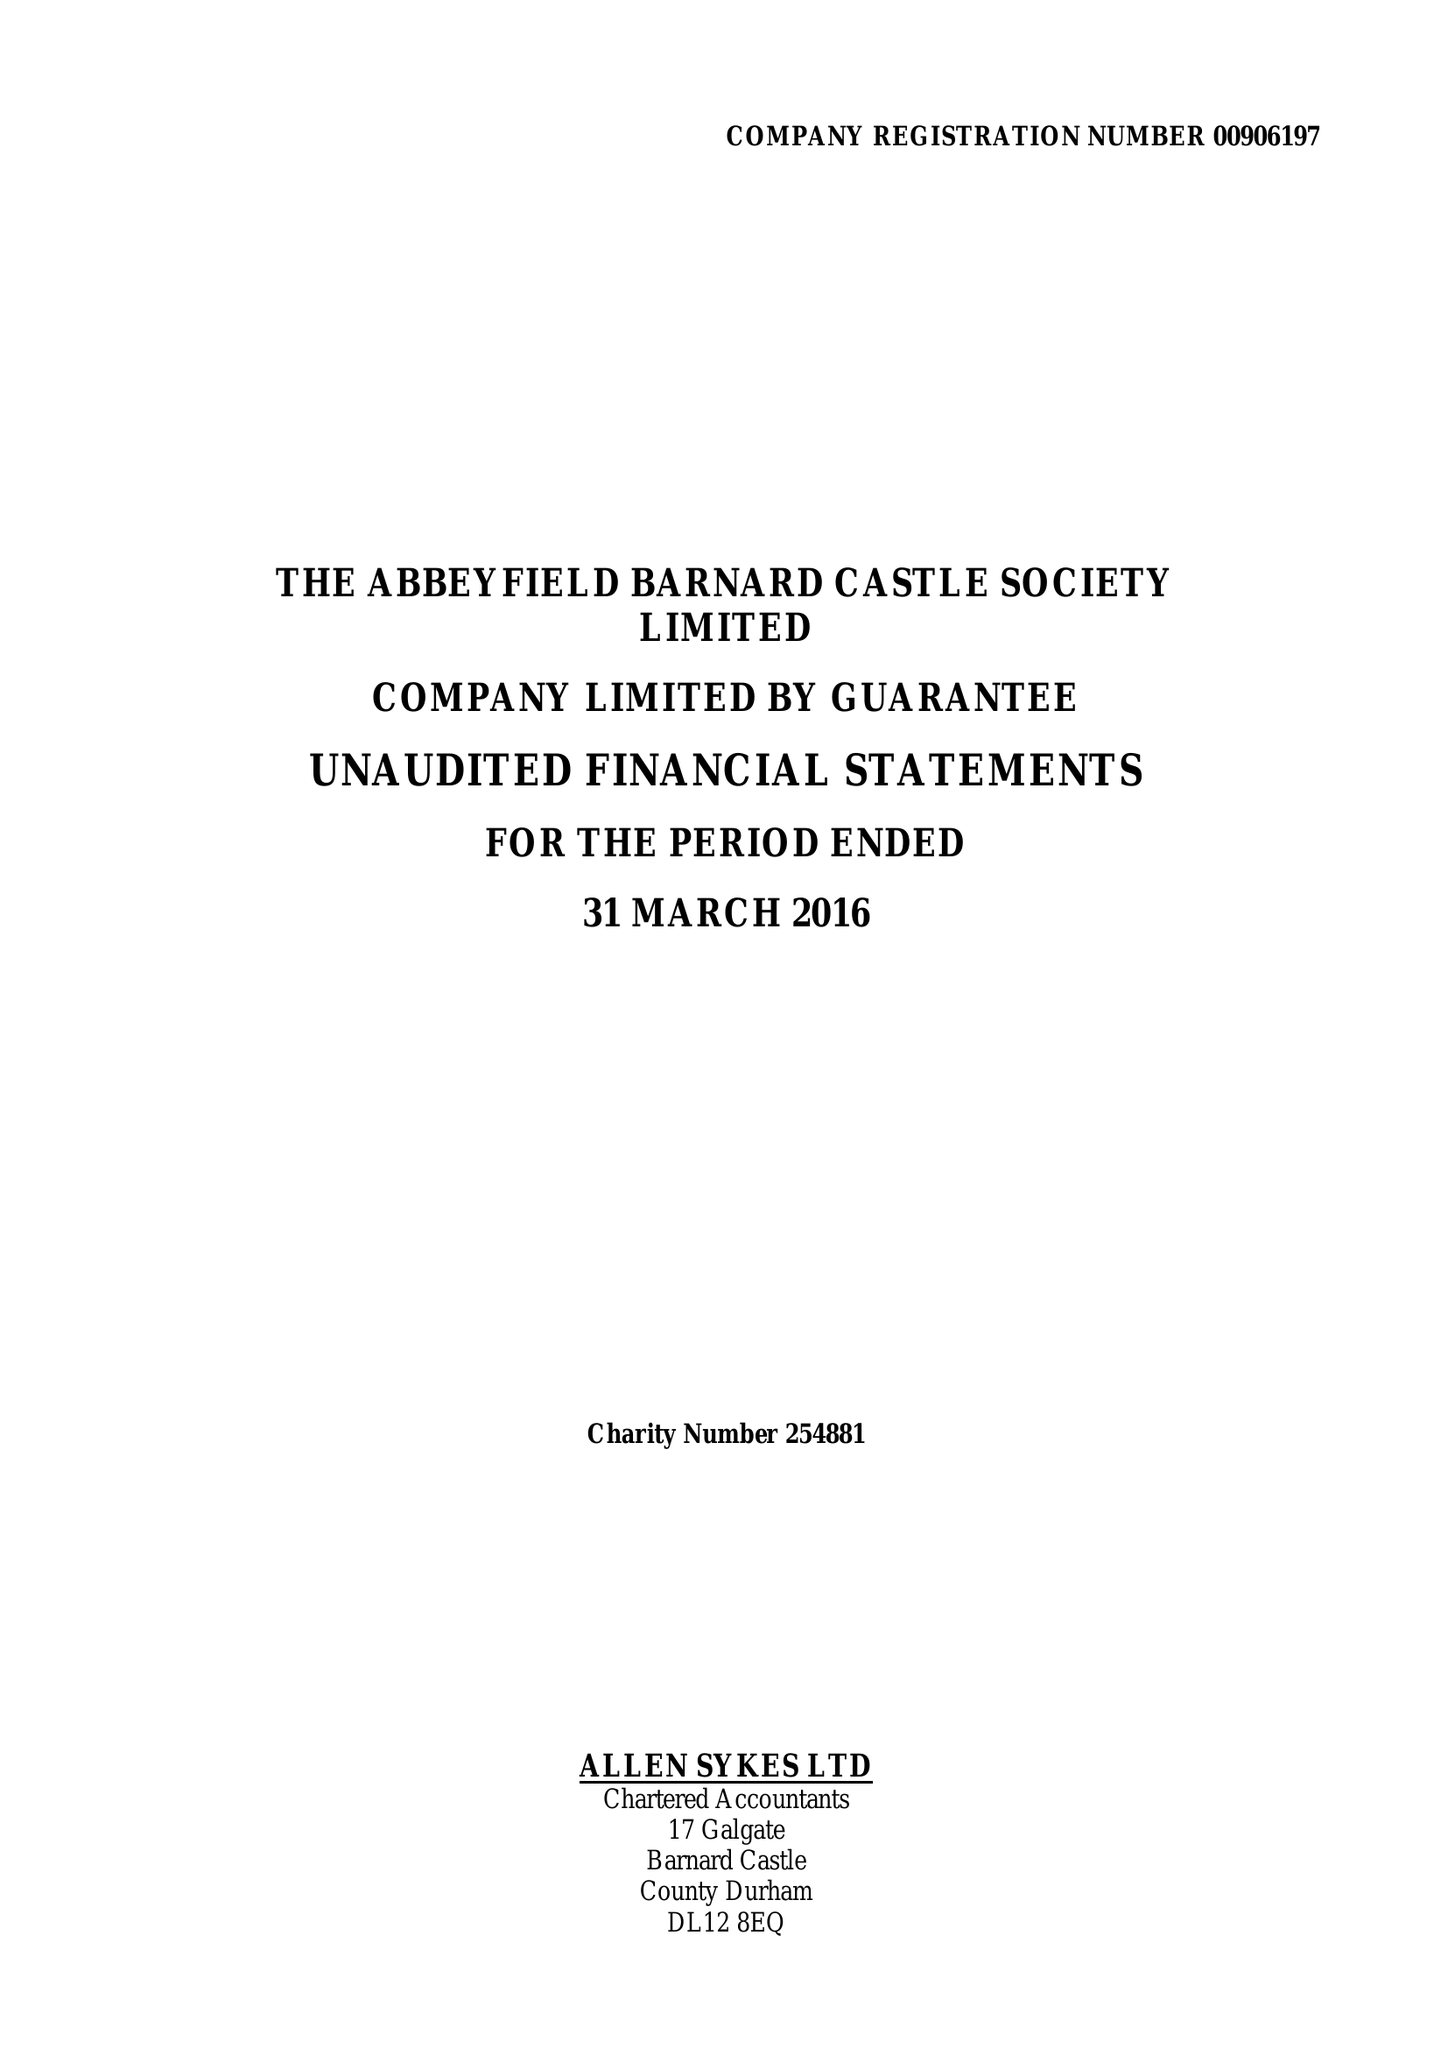What is the value for the address__post_town?
Answer the question using a single word or phrase. BARNARD CASTLE 